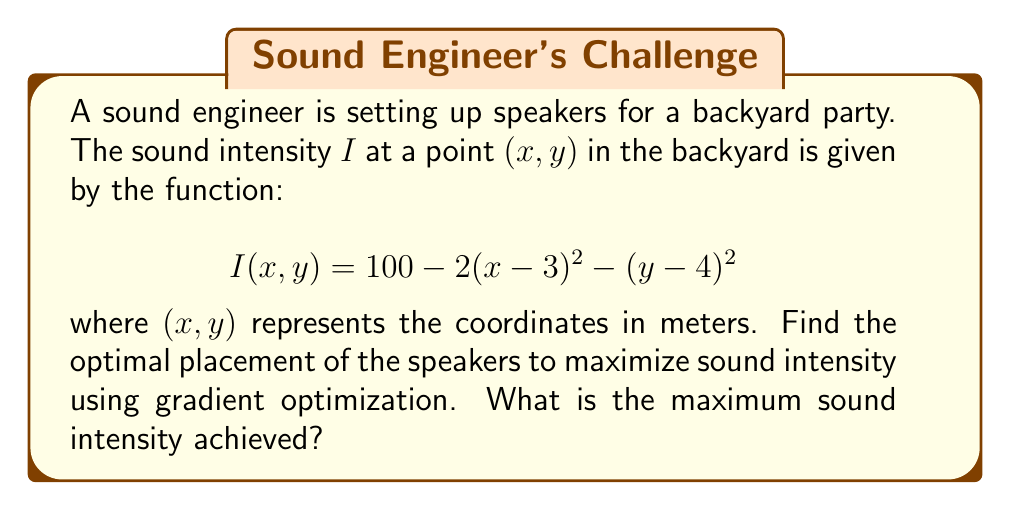Give your solution to this math problem. To find the optimal placement of speakers and maximize sound intensity, we need to use gradient optimization:

1. Calculate the gradient of $I(x,y)$:
   $$\nabla I = \left(\frac{\partial I}{\partial x}, \frac{\partial I}{\partial y}\right)$$
   $$\frac{\partial I}{\partial x} = -4(x-3)$$
   $$\frac{\partial I}{\partial y} = -2(y-4)$$
   $$\nabla I = (-4(x-3), -2(y-4))$$

2. Set the gradient equal to zero to find critical points:
   $$-4(x-3) = 0 \quad \text{and} \quad -2(y-4) = 0$$
   $$x-3 = 0 \quad \text{and} \quad y-4 = 0$$
   $$x = 3 \quad \text{and} \quad y = 4$$

3. The critical point $(3,4)$ is the only solution, which represents the optimal placement of speakers.

4. To confirm this is a maximum, we can check the second partial derivatives:
   $$\frac{\partial^2 I}{\partial x^2} = -4$$
   $$\frac{\partial^2 I}{\partial y^2} = -2$$
   Both are negative, confirming a local maximum.

5. Calculate the maximum sound intensity by plugging in the optimal coordinates:
   $$I(3,4) = 100 - 2(3-3)^2 - (4-4)^2 = 100$$

Therefore, the optimal placement for the speakers is at coordinates (3,4) meters, and the maximum sound intensity achieved is 100 units.
Answer: Optimal placement: (3,4) meters; Maximum intensity: 100 units 